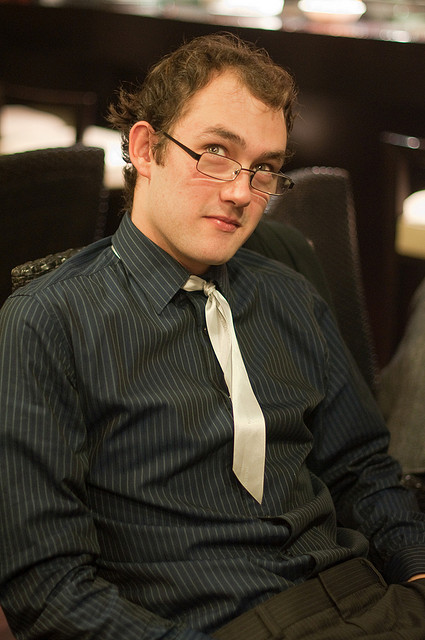<image>What sort of facial hair does this man have? It is not certain what sort of facial hair this man has. It could be none or stubble. What sort of facial hair does this man have? The man in the image doesn't have any facial hair. 